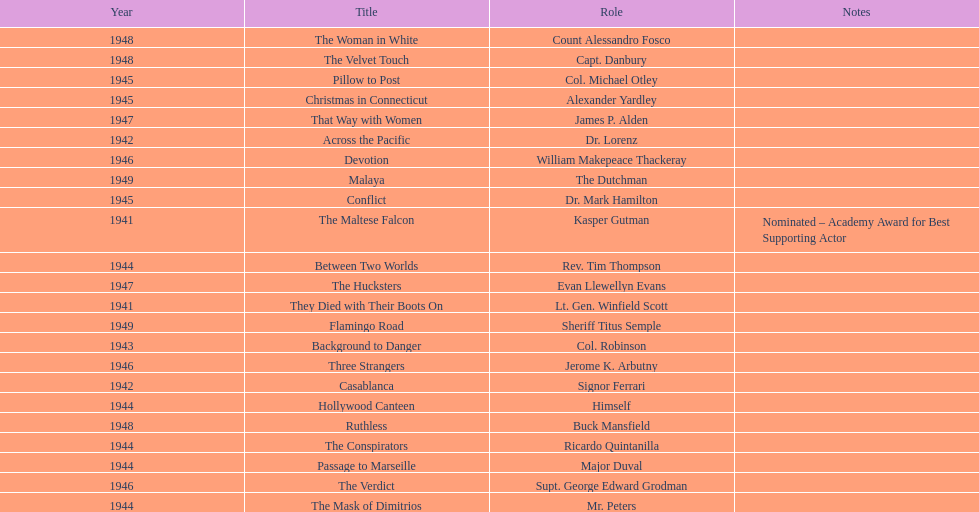What were the first and last movies greenstreet acted in? The Maltese Falcon, Malaya. 